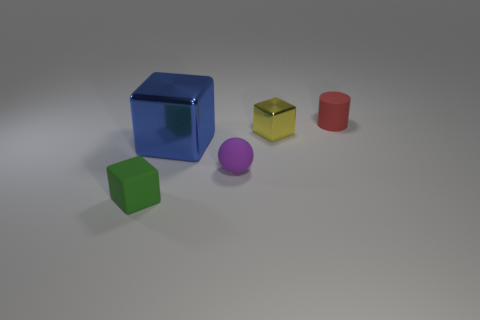Subtract all blocks. How many objects are left? 2 Add 1 tiny green matte things. How many objects exist? 6 Subtract all small cubes. How many cubes are left? 1 Subtract 0 red cubes. How many objects are left? 5 Subtract 1 cubes. How many cubes are left? 2 Subtract all brown balls. Subtract all yellow blocks. How many balls are left? 1 Subtract all blue cylinders. How many green cubes are left? 1 Subtract all tiny objects. Subtract all big cubes. How many objects are left? 0 Add 3 red cylinders. How many red cylinders are left? 4 Add 3 small red objects. How many small red objects exist? 4 